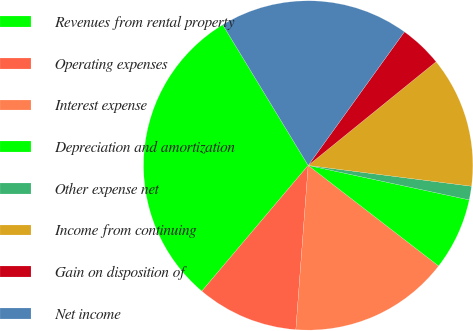Convert chart to OTSL. <chart><loc_0><loc_0><loc_500><loc_500><pie_chart><fcel>Revenues from rental property<fcel>Operating expenses<fcel>Interest expense<fcel>Depreciation and amortization<fcel>Other expense net<fcel>Income from continuing<fcel>Gain on disposition of<fcel>Net income<nl><fcel>30.14%<fcel>9.98%<fcel>15.74%<fcel>7.1%<fcel>1.34%<fcel>12.86%<fcel>4.22%<fcel>18.62%<nl></chart> 